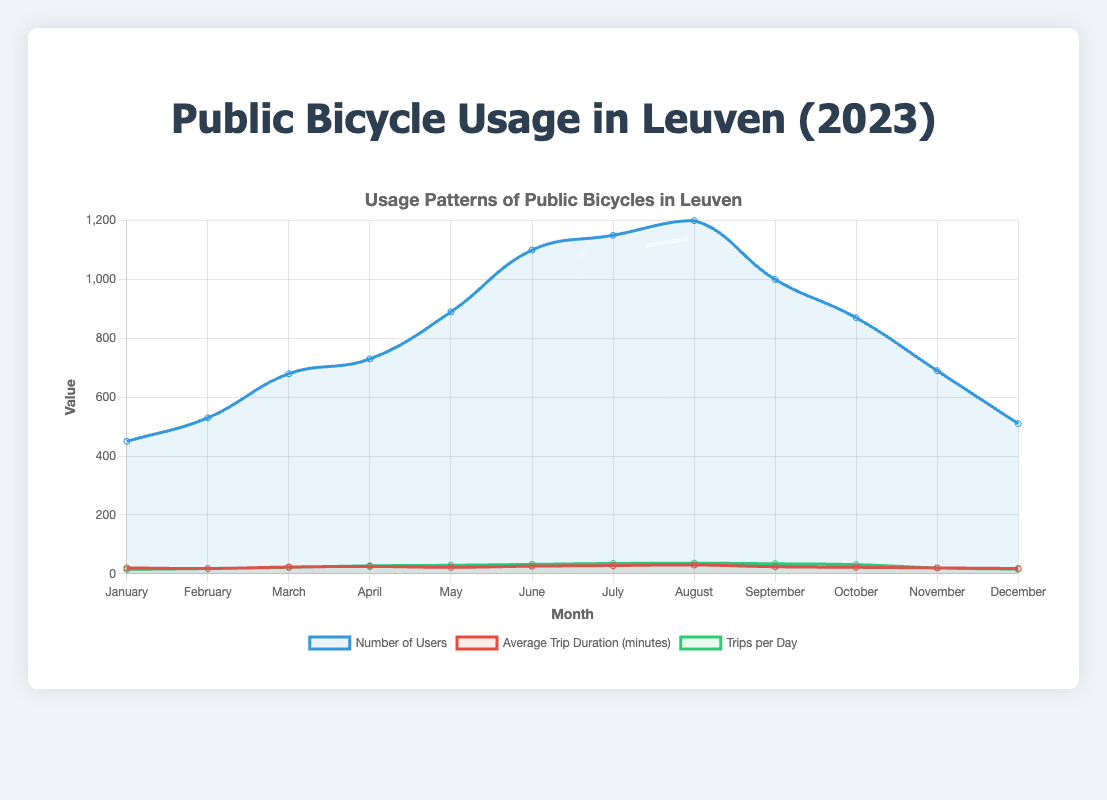What is the month with the highest number of public bicycle users and how many were there? Upon examining the figure, it's clear that the month with the highest number of users is August, as the peak point on the 'Number of Users' line coincides with August. The number of users in August is 1200.
Answer: August, 1200 During which month was the average trip duration the longest? The 'Average Trip Duration (minutes)' line has the highest point in August, indicating that the average trip duration was longest in that month.
Answer: August How many trips per day were there in July? The figure shows the Trips per Day line for July at a value of 35.
Answer: 35 Which two months have the same average trip duration, and what is that duration? The lines for 'Average Trip Duration (minutes)' in May and October both reach a value of 22 minutes, indicating they have the same average trip duration.
Answer: May and October, 22 minutes Compare the total number of users in the first quarter (January, February, March) with the second quarter (April, May, June). Which quarter had more users and by how much? Summing users for Q1: 450 (Jan) + 530 (Feb) + 680 (Mar) = 1660, and for Q2: 730 (Apr) + 890 (May) + 1100 (Jun) = 2720. The second quarter (Q2) had more users. The difference is 2720 - 1660 = 1060.
Answer: Q2, by 1060 In which month is the increase in the number of trips per day the highest compared to the previous month, and what is the value of this increase? The largest increase can be observed between March and April where the number of trips per day goes from 22 to 27. The increase is 27 - 22 = 5 trips per day.
Answer: April Which month's average trip duration is equal to the average trip duration of January plus February's? The average trip duration for January is 20 minutes and for February is 18 minutes. Summing them: 20 + 18 = 38 minutes. August's average trip duration is 30 minutes; no month matches the sum of January and February.
Answer: None What is the difference between the highest and lowest number of users in a month? The highest number of users is in August (1200) and the lowest is in January (450). The difference is 1200 - 450 = 750.
Answer: 750 In which two consecutive months did the number of users see the largest drop, and what was the value of this drop? The largest drop is between August and September where users decrease from 1200 to 1000. The value of this drop is 1200 - 1000 = 200 users.
Answer: August to September, 200 users Do the most popular and least popular stations change more frequently in the first half of the year or the second half? In the first half (January to June), the most popular station is consistently Leuven Train Station, except in March (Minckelersstraat). The least popular alternates between Keizersberg Abbey and Minckelersstraat for three months each. The second half (July to December) sees more changes for the most popular station: Leuven Train Station (for four months instead of five in first half) and Old Market Square. The least popular stations change similarly to the first half.
Answer: Second half 